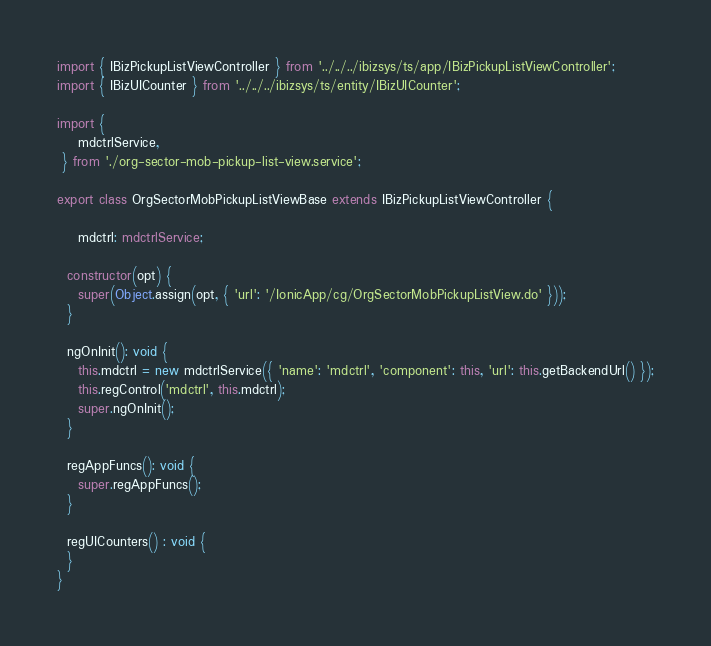Convert code to text. <code><loc_0><loc_0><loc_500><loc_500><_TypeScript_>import { IBizPickupListViewController } from '../../../ibizsys/ts/app/IBizPickupListViewController';
import { IBizUICounter } from '../../../ibizsys/ts/entity/IBizUICounter';

import {
	mdctrlService,
 } from './org-sector-mob-pickup-list-view.service';

export class OrgSectorMobPickupListViewBase extends IBizPickupListViewController {

    mdctrl: mdctrlService;

  constructor(opt) {
    super(Object.assign(opt, { 'url': '/IonicApp/cg/OrgSectorMobPickupListView.do' }));
  }

  ngOnInit(): void {
    this.mdctrl = new mdctrlService({ 'name': 'mdctrl', 'component': this, 'url': this.getBackendUrl() });
    this.regControl('mdctrl', this.mdctrl);
    super.ngOnInit();
  }

  regAppFuncs(): void {
    super.regAppFuncs();
  }

  regUICounters() : void {
  }
}</code> 